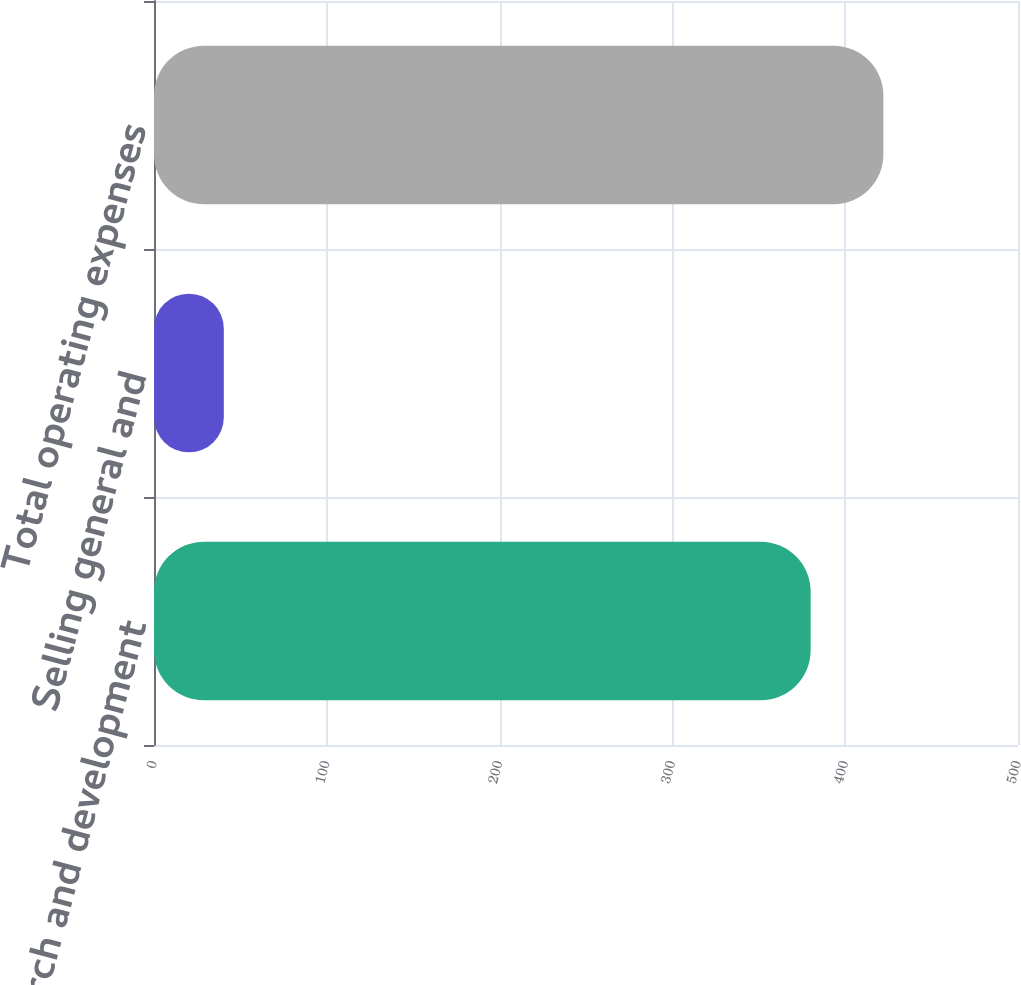Convert chart. <chart><loc_0><loc_0><loc_500><loc_500><bar_chart><fcel>Research and development<fcel>Selling general and<fcel>Total operating expenses<nl><fcel>380<fcel>40.4<fcel>422.1<nl></chart> 